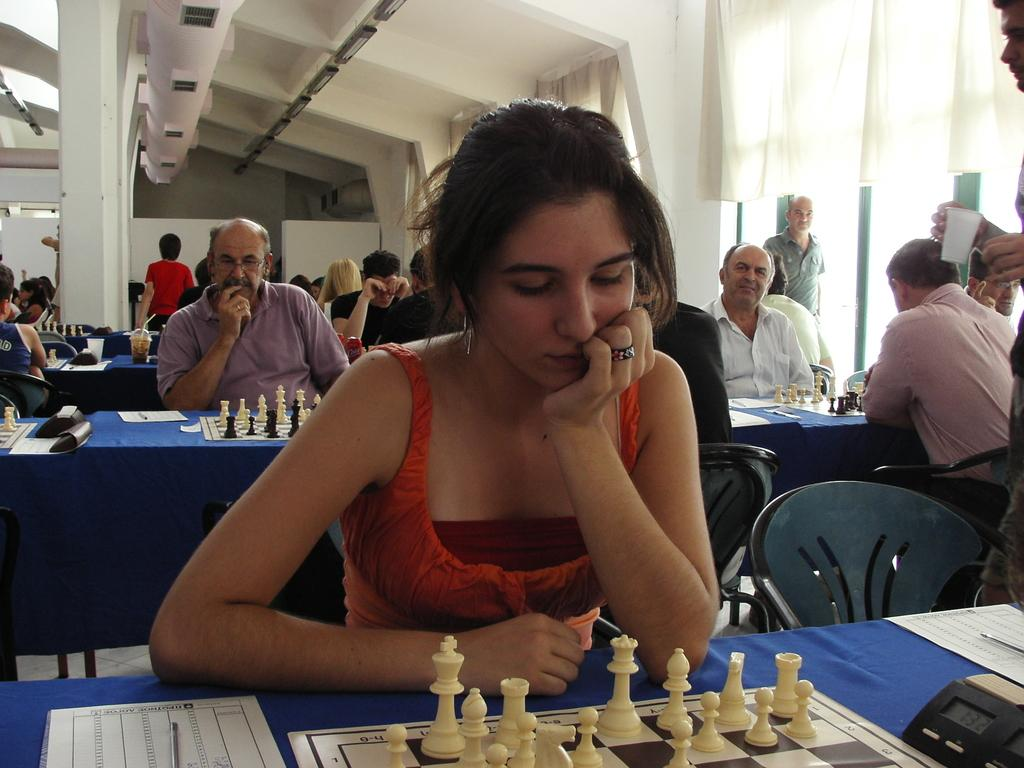Who is the main subject in the image? There is a woman in the image. What is the woman wearing? The woman is wearing a red dress. What activity is the woman engaged in? The woman is playing chess. Where is the chessboard placed? The chessboard is placed on a table. What is the color of the mat on the table? The table has a blue mat on it. Are there any other people involved in the same activity in the image? Yes, there are other people playing chess in the background. What type of store can be seen in the background of the image? There is no store visible in the image; it features a woman playing chess with other people in the background. How many cards does the woman have in her hand while playing chess? The woman is playing chess, not a card game, so she does not have any cards in her hand. 